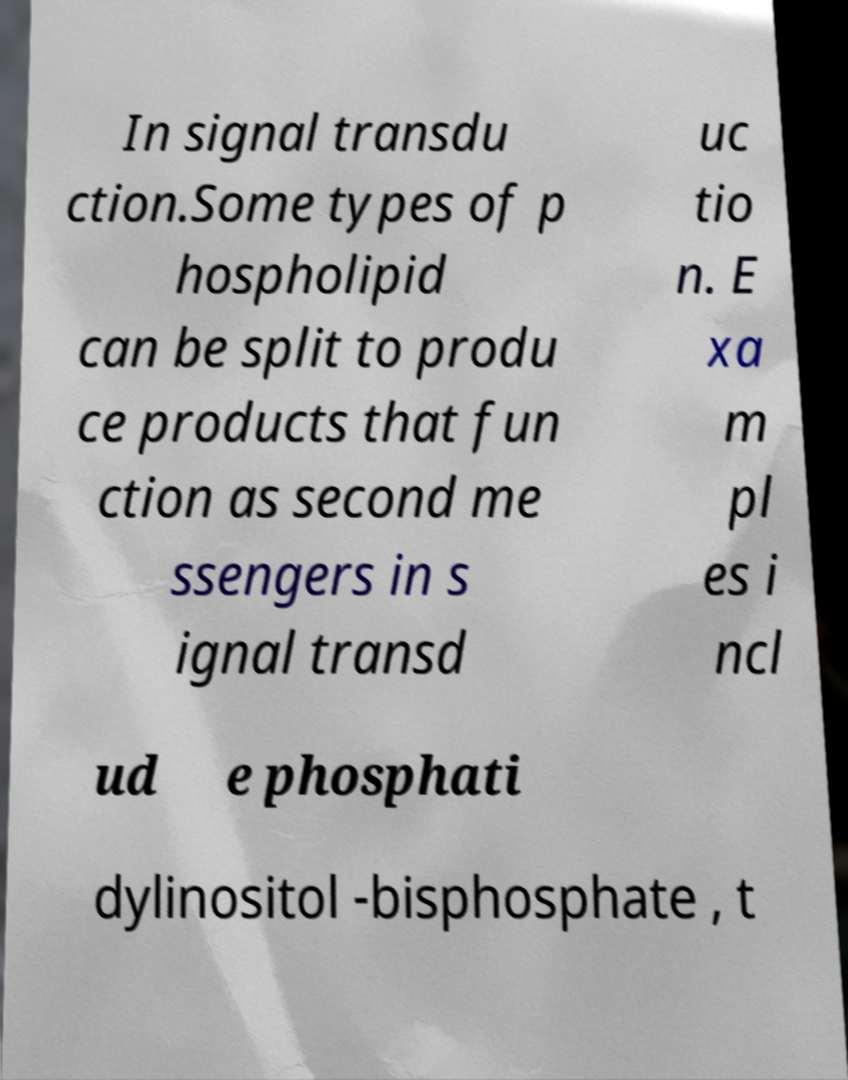Please identify and transcribe the text found in this image. In signal transdu ction.Some types of p hospholipid can be split to produ ce products that fun ction as second me ssengers in s ignal transd uc tio n. E xa m pl es i ncl ud e phosphati dylinositol -bisphosphate , t 